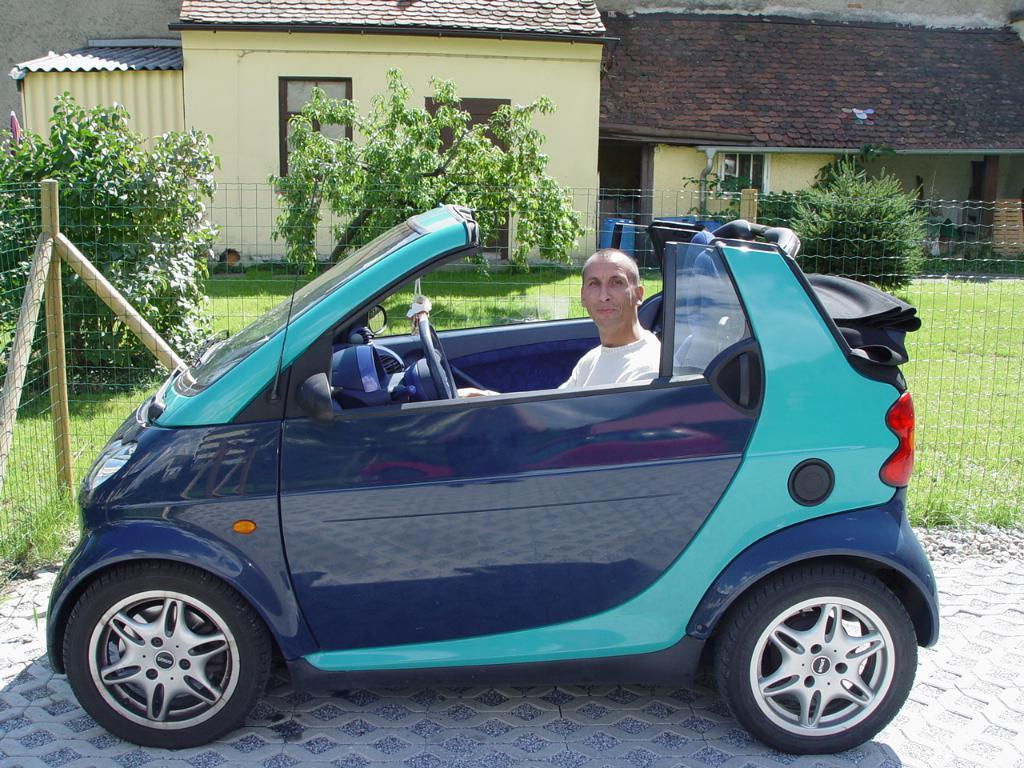What is the main subject in the center of the image? There is a car in the center of the image. Who or what is inside the car? There is a man inside the car. What can be seen in the background of the image? There is a house, a window, a door, trees, a fence, and grass in the background of the image. What type of flock is flying over the car in the image? There is no flock of birds or any other animals visible in the image. Is there a battle taking place in the background of the image? There is no indication of a battle or any conflict in the image. 